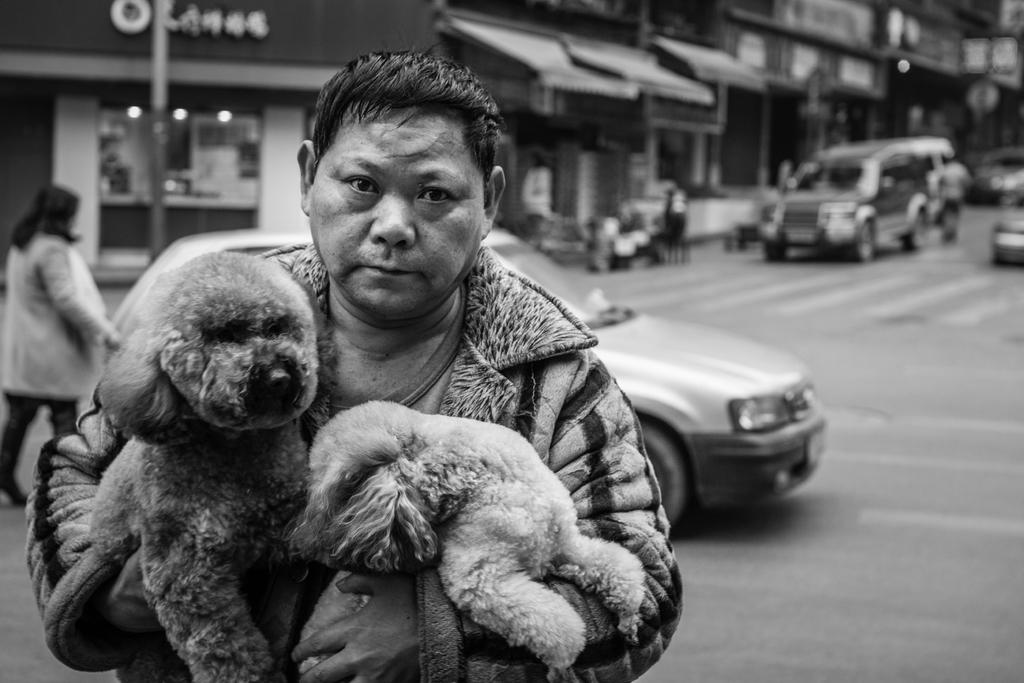What is the main subject of the image? There is a guy in the image. What is the guy doing in the image? The guy is holding two dogs with both hands. What can be seen in the background of the image? There is a car and a woman in the background of the image. Where was the image taken? The image was taken on a road. What type of loaf is being advertised on the side of the car in the image? There is no loaf or advertisement present on the side of the car in the image. What vegetables are visible in the image? There are no vegetables visible in the image. 